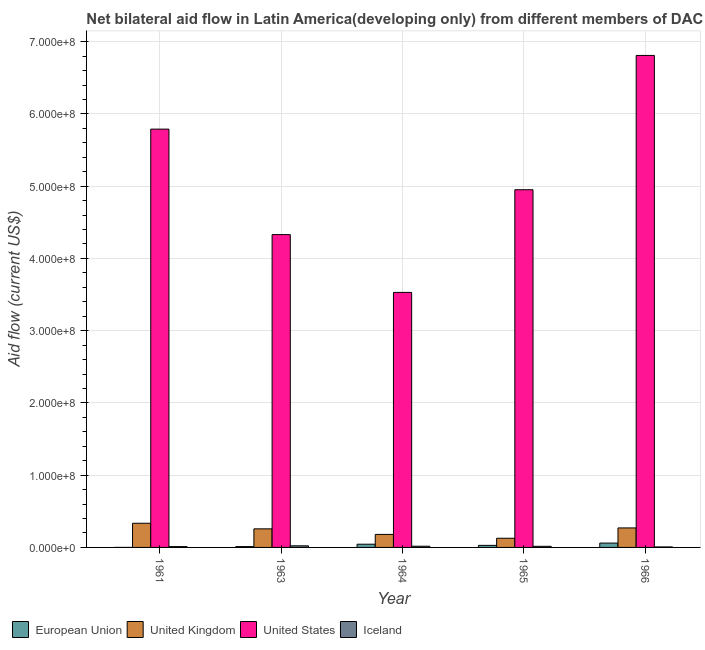How many different coloured bars are there?
Provide a short and direct response. 4. How many groups of bars are there?
Offer a very short reply. 5. What is the label of the 4th group of bars from the left?
Your answer should be compact. 1965. What is the amount of aid given by iceland in 1965?
Your answer should be compact. 1.53e+06. Across all years, what is the maximum amount of aid given by iceland?
Provide a succinct answer. 2.23e+06. Across all years, what is the minimum amount of aid given by iceland?
Ensure brevity in your answer.  6.80e+05. In which year was the amount of aid given by us maximum?
Your answer should be compact. 1966. In which year was the amount of aid given by iceland minimum?
Offer a very short reply. 1966. What is the total amount of aid given by eu in the graph?
Make the answer very short. 1.45e+07. What is the difference between the amount of aid given by iceland in 1961 and that in 1965?
Make the answer very short. -4.00e+05. What is the difference between the amount of aid given by iceland in 1964 and the amount of aid given by uk in 1961?
Keep it short and to the point. 5.40e+05. What is the average amount of aid given by eu per year?
Make the answer very short. 2.89e+06. What is the ratio of the amount of aid given by us in 1964 to that in 1965?
Offer a terse response. 0.71. Is the amount of aid given by uk in 1963 less than that in 1966?
Your answer should be compact. Yes. What is the difference between the highest and the second highest amount of aid given by us?
Ensure brevity in your answer.  1.02e+08. What is the difference between the highest and the lowest amount of aid given by eu?
Your answer should be compact. 6.00e+06. Is it the case that in every year, the sum of the amount of aid given by uk and amount of aid given by eu is greater than the sum of amount of aid given by us and amount of aid given by iceland?
Your answer should be compact. Yes. Is it the case that in every year, the sum of the amount of aid given by eu and amount of aid given by uk is greater than the amount of aid given by us?
Your answer should be very brief. No. How many bars are there?
Ensure brevity in your answer.  20. How many years are there in the graph?
Provide a succinct answer. 5. Are the values on the major ticks of Y-axis written in scientific E-notation?
Make the answer very short. Yes. Does the graph contain any zero values?
Your answer should be very brief. No. How are the legend labels stacked?
Ensure brevity in your answer.  Horizontal. What is the title of the graph?
Offer a terse response. Net bilateral aid flow in Latin America(developing only) from different members of DAC. What is the label or title of the Y-axis?
Offer a terse response. Aid flow (current US$). What is the Aid flow (current US$) of United Kingdom in 1961?
Keep it short and to the point. 3.34e+07. What is the Aid flow (current US$) of United States in 1961?
Ensure brevity in your answer.  5.79e+08. What is the Aid flow (current US$) of Iceland in 1961?
Your answer should be very brief. 1.13e+06. What is the Aid flow (current US$) in European Union in 1963?
Ensure brevity in your answer.  1.14e+06. What is the Aid flow (current US$) in United Kingdom in 1963?
Give a very brief answer. 2.57e+07. What is the Aid flow (current US$) of United States in 1963?
Give a very brief answer. 4.33e+08. What is the Aid flow (current US$) in Iceland in 1963?
Offer a terse response. 2.23e+06. What is the Aid flow (current US$) of European Union in 1964?
Keep it short and to the point. 4.45e+06. What is the Aid flow (current US$) of United Kingdom in 1964?
Your response must be concise. 1.80e+07. What is the Aid flow (current US$) of United States in 1964?
Keep it short and to the point. 3.53e+08. What is the Aid flow (current US$) of Iceland in 1964?
Offer a very short reply. 1.67e+06. What is the Aid flow (current US$) of European Union in 1965?
Give a very brief answer. 2.85e+06. What is the Aid flow (current US$) of United Kingdom in 1965?
Give a very brief answer. 1.27e+07. What is the Aid flow (current US$) in United States in 1965?
Your answer should be compact. 4.95e+08. What is the Aid flow (current US$) in Iceland in 1965?
Your answer should be very brief. 1.53e+06. What is the Aid flow (current US$) in European Union in 1966?
Give a very brief answer. 6.01e+06. What is the Aid flow (current US$) in United Kingdom in 1966?
Offer a very short reply. 2.70e+07. What is the Aid flow (current US$) of United States in 1966?
Offer a terse response. 6.81e+08. What is the Aid flow (current US$) in Iceland in 1966?
Offer a very short reply. 6.80e+05. Across all years, what is the maximum Aid flow (current US$) of European Union?
Provide a succinct answer. 6.01e+06. Across all years, what is the maximum Aid flow (current US$) of United Kingdom?
Make the answer very short. 3.34e+07. Across all years, what is the maximum Aid flow (current US$) in United States?
Provide a short and direct response. 6.81e+08. Across all years, what is the maximum Aid flow (current US$) of Iceland?
Provide a short and direct response. 2.23e+06. Across all years, what is the minimum Aid flow (current US$) of European Union?
Make the answer very short. 10000. Across all years, what is the minimum Aid flow (current US$) in United Kingdom?
Offer a very short reply. 1.27e+07. Across all years, what is the minimum Aid flow (current US$) of United States?
Keep it short and to the point. 3.53e+08. Across all years, what is the minimum Aid flow (current US$) in Iceland?
Offer a very short reply. 6.80e+05. What is the total Aid flow (current US$) of European Union in the graph?
Your answer should be very brief. 1.45e+07. What is the total Aid flow (current US$) of United Kingdom in the graph?
Keep it short and to the point. 1.17e+08. What is the total Aid flow (current US$) in United States in the graph?
Offer a terse response. 2.54e+09. What is the total Aid flow (current US$) in Iceland in the graph?
Your answer should be very brief. 7.24e+06. What is the difference between the Aid flow (current US$) in European Union in 1961 and that in 1963?
Your answer should be very brief. -1.13e+06. What is the difference between the Aid flow (current US$) of United Kingdom in 1961 and that in 1963?
Your answer should be compact. 7.73e+06. What is the difference between the Aid flow (current US$) of United States in 1961 and that in 1963?
Offer a terse response. 1.46e+08. What is the difference between the Aid flow (current US$) of Iceland in 1961 and that in 1963?
Offer a very short reply. -1.10e+06. What is the difference between the Aid flow (current US$) in European Union in 1961 and that in 1964?
Provide a succinct answer. -4.44e+06. What is the difference between the Aid flow (current US$) of United Kingdom in 1961 and that in 1964?
Keep it short and to the point. 1.54e+07. What is the difference between the Aid flow (current US$) of United States in 1961 and that in 1964?
Keep it short and to the point. 2.26e+08. What is the difference between the Aid flow (current US$) in Iceland in 1961 and that in 1964?
Make the answer very short. -5.40e+05. What is the difference between the Aid flow (current US$) of European Union in 1961 and that in 1965?
Give a very brief answer. -2.84e+06. What is the difference between the Aid flow (current US$) in United Kingdom in 1961 and that in 1965?
Your answer should be very brief. 2.07e+07. What is the difference between the Aid flow (current US$) of United States in 1961 and that in 1965?
Give a very brief answer. 8.39e+07. What is the difference between the Aid flow (current US$) of Iceland in 1961 and that in 1965?
Ensure brevity in your answer.  -4.00e+05. What is the difference between the Aid flow (current US$) in European Union in 1961 and that in 1966?
Provide a short and direct response. -6.00e+06. What is the difference between the Aid flow (current US$) of United Kingdom in 1961 and that in 1966?
Offer a terse response. 6.46e+06. What is the difference between the Aid flow (current US$) in United States in 1961 and that in 1966?
Make the answer very short. -1.02e+08. What is the difference between the Aid flow (current US$) of Iceland in 1961 and that in 1966?
Ensure brevity in your answer.  4.50e+05. What is the difference between the Aid flow (current US$) of European Union in 1963 and that in 1964?
Your answer should be very brief. -3.31e+06. What is the difference between the Aid flow (current US$) in United Kingdom in 1963 and that in 1964?
Your answer should be very brief. 7.70e+06. What is the difference between the Aid flow (current US$) in United States in 1963 and that in 1964?
Your answer should be compact. 8.00e+07. What is the difference between the Aid flow (current US$) of Iceland in 1963 and that in 1964?
Keep it short and to the point. 5.60e+05. What is the difference between the Aid flow (current US$) in European Union in 1963 and that in 1965?
Offer a very short reply. -1.71e+06. What is the difference between the Aid flow (current US$) in United Kingdom in 1963 and that in 1965?
Keep it short and to the point. 1.30e+07. What is the difference between the Aid flow (current US$) of United States in 1963 and that in 1965?
Your answer should be compact. -6.21e+07. What is the difference between the Aid flow (current US$) of Iceland in 1963 and that in 1965?
Provide a succinct answer. 7.00e+05. What is the difference between the Aid flow (current US$) of European Union in 1963 and that in 1966?
Offer a very short reply. -4.87e+06. What is the difference between the Aid flow (current US$) in United Kingdom in 1963 and that in 1966?
Your response must be concise. -1.27e+06. What is the difference between the Aid flow (current US$) in United States in 1963 and that in 1966?
Your answer should be very brief. -2.48e+08. What is the difference between the Aid flow (current US$) of Iceland in 1963 and that in 1966?
Provide a short and direct response. 1.55e+06. What is the difference between the Aid flow (current US$) of European Union in 1964 and that in 1965?
Provide a short and direct response. 1.60e+06. What is the difference between the Aid flow (current US$) in United Kingdom in 1964 and that in 1965?
Your answer should be very brief. 5.31e+06. What is the difference between the Aid flow (current US$) of United States in 1964 and that in 1965?
Your answer should be very brief. -1.42e+08. What is the difference between the Aid flow (current US$) in Iceland in 1964 and that in 1965?
Make the answer very short. 1.40e+05. What is the difference between the Aid flow (current US$) of European Union in 1964 and that in 1966?
Ensure brevity in your answer.  -1.56e+06. What is the difference between the Aid flow (current US$) of United Kingdom in 1964 and that in 1966?
Offer a very short reply. -8.97e+06. What is the difference between the Aid flow (current US$) of United States in 1964 and that in 1966?
Your answer should be compact. -3.28e+08. What is the difference between the Aid flow (current US$) of Iceland in 1964 and that in 1966?
Your response must be concise. 9.90e+05. What is the difference between the Aid flow (current US$) in European Union in 1965 and that in 1966?
Provide a succinct answer. -3.16e+06. What is the difference between the Aid flow (current US$) of United Kingdom in 1965 and that in 1966?
Your response must be concise. -1.43e+07. What is the difference between the Aid flow (current US$) of United States in 1965 and that in 1966?
Your answer should be compact. -1.86e+08. What is the difference between the Aid flow (current US$) in Iceland in 1965 and that in 1966?
Give a very brief answer. 8.50e+05. What is the difference between the Aid flow (current US$) in European Union in 1961 and the Aid flow (current US$) in United Kingdom in 1963?
Ensure brevity in your answer.  -2.57e+07. What is the difference between the Aid flow (current US$) of European Union in 1961 and the Aid flow (current US$) of United States in 1963?
Your response must be concise. -4.33e+08. What is the difference between the Aid flow (current US$) in European Union in 1961 and the Aid flow (current US$) in Iceland in 1963?
Your answer should be very brief. -2.22e+06. What is the difference between the Aid flow (current US$) of United Kingdom in 1961 and the Aid flow (current US$) of United States in 1963?
Keep it short and to the point. -4.00e+08. What is the difference between the Aid flow (current US$) in United Kingdom in 1961 and the Aid flow (current US$) in Iceland in 1963?
Provide a short and direct response. 3.12e+07. What is the difference between the Aid flow (current US$) in United States in 1961 and the Aid flow (current US$) in Iceland in 1963?
Keep it short and to the point. 5.77e+08. What is the difference between the Aid flow (current US$) in European Union in 1961 and the Aid flow (current US$) in United Kingdom in 1964?
Offer a terse response. -1.80e+07. What is the difference between the Aid flow (current US$) of European Union in 1961 and the Aid flow (current US$) of United States in 1964?
Ensure brevity in your answer.  -3.53e+08. What is the difference between the Aid flow (current US$) in European Union in 1961 and the Aid flow (current US$) in Iceland in 1964?
Ensure brevity in your answer.  -1.66e+06. What is the difference between the Aid flow (current US$) of United Kingdom in 1961 and the Aid flow (current US$) of United States in 1964?
Offer a very short reply. -3.20e+08. What is the difference between the Aid flow (current US$) of United Kingdom in 1961 and the Aid flow (current US$) of Iceland in 1964?
Make the answer very short. 3.18e+07. What is the difference between the Aid flow (current US$) in United States in 1961 and the Aid flow (current US$) in Iceland in 1964?
Provide a succinct answer. 5.77e+08. What is the difference between the Aid flow (current US$) in European Union in 1961 and the Aid flow (current US$) in United Kingdom in 1965?
Make the answer very short. -1.27e+07. What is the difference between the Aid flow (current US$) in European Union in 1961 and the Aid flow (current US$) in United States in 1965?
Your answer should be compact. -4.95e+08. What is the difference between the Aid flow (current US$) of European Union in 1961 and the Aid flow (current US$) of Iceland in 1965?
Keep it short and to the point. -1.52e+06. What is the difference between the Aid flow (current US$) of United Kingdom in 1961 and the Aid flow (current US$) of United States in 1965?
Your answer should be compact. -4.62e+08. What is the difference between the Aid flow (current US$) of United Kingdom in 1961 and the Aid flow (current US$) of Iceland in 1965?
Provide a short and direct response. 3.19e+07. What is the difference between the Aid flow (current US$) in United States in 1961 and the Aid flow (current US$) in Iceland in 1965?
Keep it short and to the point. 5.77e+08. What is the difference between the Aid flow (current US$) of European Union in 1961 and the Aid flow (current US$) of United Kingdom in 1966?
Keep it short and to the point. -2.70e+07. What is the difference between the Aid flow (current US$) in European Union in 1961 and the Aid flow (current US$) in United States in 1966?
Give a very brief answer. -6.81e+08. What is the difference between the Aid flow (current US$) in European Union in 1961 and the Aid flow (current US$) in Iceland in 1966?
Keep it short and to the point. -6.70e+05. What is the difference between the Aid flow (current US$) of United Kingdom in 1961 and the Aid flow (current US$) of United States in 1966?
Offer a very short reply. -6.48e+08. What is the difference between the Aid flow (current US$) of United Kingdom in 1961 and the Aid flow (current US$) of Iceland in 1966?
Your answer should be very brief. 3.28e+07. What is the difference between the Aid flow (current US$) in United States in 1961 and the Aid flow (current US$) in Iceland in 1966?
Provide a short and direct response. 5.78e+08. What is the difference between the Aid flow (current US$) of European Union in 1963 and the Aid flow (current US$) of United Kingdom in 1964?
Your answer should be compact. -1.69e+07. What is the difference between the Aid flow (current US$) in European Union in 1963 and the Aid flow (current US$) in United States in 1964?
Ensure brevity in your answer.  -3.52e+08. What is the difference between the Aid flow (current US$) of European Union in 1963 and the Aid flow (current US$) of Iceland in 1964?
Offer a very short reply. -5.30e+05. What is the difference between the Aid flow (current US$) of United Kingdom in 1963 and the Aid flow (current US$) of United States in 1964?
Make the answer very short. -3.27e+08. What is the difference between the Aid flow (current US$) of United Kingdom in 1963 and the Aid flow (current US$) of Iceland in 1964?
Provide a succinct answer. 2.40e+07. What is the difference between the Aid flow (current US$) in United States in 1963 and the Aid flow (current US$) in Iceland in 1964?
Your answer should be very brief. 4.31e+08. What is the difference between the Aid flow (current US$) of European Union in 1963 and the Aid flow (current US$) of United Kingdom in 1965?
Keep it short and to the point. -1.16e+07. What is the difference between the Aid flow (current US$) of European Union in 1963 and the Aid flow (current US$) of United States in 1965?
Ensure brevity in your answer.  -4.94e+08. What is the difference between the Aid flow (current US$) of European Union in 1963 and the Aid flow (current US$) of Iceland in 1965?
Offer a very short reply. -3.90e+05. What is the difference between the Aid flow (current US$) in United Kingdom in 1963 and the Aid flow (current US$) in United States in 1965?
Give a very brief answer. -4.69e+08. What is the difference between the Aid flow (current US$) in United Kingdom in 1963 and the Aid flow (current US$) in Iceland in 1965?
Your answer should be very brief. 2.42e+07. What is the difference between the Aid flow (current US$) in United States in 1963 and the Aid flow (current US$) in Iceland in 1965?
Your response must be concise. 4.31e+08. What is the difference between the Aid flow (current US$) of European Union in 1963 and the Aid flow (current US$) of United Kingdom in 1966?
Ensure brevity in your answer.  -2.58e+07. What is the difference between the Aid flow (current US$) of European Union in 1963 and the Aid flow (current US$) of United States in 1966?
Provide a succinct answer. -6.80e+08. What is the difference between the Aid flow (current US$) of European Union in 1963 and the Aid flow (current US$) of Iceland in 1966?
Provide a succinct answer. 4.60e+05. What is the difference between the Aid flow (current US$) in United Kingdom in 1963 and the Aid flow (current US$) in United States in 1966?
Offer a very short reply. -6.55e+08. What is the difference between the Aid flow (current US$) in United Kingdom in 1963 and the Aid flow (current US$) in Iceland in 1966?
Offer a terse response. 2.50e+07. What is the difference between the Aid flow (current US$) of United States in 1963 and the Aid flow (current US$) of Iceland in 1966?
Provide a short and direct response. 4.32e+08. What is the difference between the Aid flow (current US$) of European Union in 1964 and the Aid flow (current US$) of United Kingdom in 1965?
Your response must be concise. -8.26e+06. What is the difference between the Aid flow (current US$) of European Union in 1964 and the Aid flow (current US$) of United States in 1965?
Make the answer very short. -4.91e+08. What is the difference between the Aid flow (current US$) in European Union in 1964 and the Aid flow (current US$) in Iceland in 1965?
Your answer should be compact. 2.92e+06. What is the difference between the Aid flow (current US$) in United Kingdom in 1964 and the Aid flow (current US$) in United States in 1965?
Ensure brevity in your answer.  -4.77e+08. What is the difference between the Aid flow (current US$) of United Kingdom in 1964 and the Aid flow (current US$) of Iceland in 1965?
Make the answer very short. 1.65e+07. What is the difference between the Aid flow (current US$) of United States in 1964 and the Aid flow (current US$) of Iceland in 1965?
Provide a succinct answer. 3.51e+08. What is the difference between the Aid flow (current US$) of European Union in 1964 and the Aid flow (current US$) of United Kingdom in 1966?
Your answer should be compact. -2.25e+07. What is the difference between the Aid flow (current US$) in European Union in 1964 and the Aid flow (current US$) in United States in 1966?
Provide a short and direct response. -6.77e+08. What is the difference between the Aid flow (current US$) in European Union in 1964 and the Aid flow (current US$) in Iceland in 1966?
Your response must be concise. 3.77e+06. What is the difference between the Aid flow (current US$) of United Kingdom in 1964 and the Aid flow (current US$) of United States in 1966?
Your response must be concise. -6.63e+08. What is the difference between the Aid flow (current US$) of United Kingdom in 1964 and the Aid flow (current US$) of Iceland in 1966?
Provide a succinct answer. 1.73e+07. What is the difference between the Aid flow (current US$) in United States in 1964 and the Aid flow (current US$) in Iceland in 1966?
Your answer should be compact. 3.52e+08. What is the difference between the Aid flow (current US$) in European Union in 1965 and the Aid flow (current US$) in United Kingdom in 1966?
Keep it short and to the point. -2.41e+07. What is the difference between the Aid flow (current US$) of European Union in 1965 and the Aid flow (current US$) of United States in 1966?
Offer a terse response. -6.78e+08. What is the difference between the Aid flow (current US$) in European Union in 1965 and the Aid flow (current US$) in Iceland in 1966?
Your response must be concise. 2.17e+06. What is the difference between the Aid flow (current US$) in United Kingdom in 1965 and the Aid flow (current US$) in United States in 1966?
Keep it short and to the point. -6.68e+08. What is the difference between the Aid flow (current US$) in United Kingdom in 1965 and the Aid flow (current US$) in Iceland in 1966?
Your response must be concise. 1.20e+07. What is the difference between the Aid flow (current US$) in United States in 1965 and the Aid flow (current US$) in Iceland in 1966?
Keep it short and to the point. 4.94e+08. What is the average Aid flow (current US$) of European Union per year?
Offer a terse response. 2.89e+06. What is the average Aid flow (current US$) of United Kingdom per year?
Your answer should be very brief. 2.34e+07. What is the average Aid flow (current US$) in United States per year?
Offer a terse response. 5.08e+08. What is the average Aid flow (current US$) in Iceland per year?
Keep it short and to the point. 1.45e+06. In the year 1961, what is the difference between the Aid flow (current US$) of European Union and Aid flow (current US$) of United Kingdom?
Your answer should be compact. -3.34e+07. In the year 1961, what is the difference between the Aid flow (current US$) in European Union and Aid flow (current US$) in United States?
Offer a very short reply. -5.79e+08. In the year 1961, what is the difference between the Aid flow (current US$) in European Union and Aid flow (current US$) in Iceland?
Ensure brevity in your answer.  -1.12e+06. In the year 1961, what is the difference between the Aid flow (current US$) in United Kingdom and Aid flow (current US$) in United States?
Your answer should be very brief. -5.46e+08. In the year 1961, what is the difference between the Aid flow (current US$) in United Kingdom and Aid flow (current US$) in Iceland?
Provide a succinct answer. 3.23e+07. In the year 1961, what is the difference between the Aid flow (current US$) of United States and Aid flow (current US$) of Iceland?
Give a very brief answer. 5.78e+08. In the year 1963, what is the difference between the Aid flow (current US$) in European Union and Aid flow (current US$) in United Kingdom?
Ensure brevity in your answer.  -2.46e+07. In the year 1963, what is the difference between the Aid flow (current US$) in European Union and Aid flow (current US$) in United States?
Ensure brevity in your answer.  -4.32e+08. In the year 1963, what is the difference between the Aid flow (current US$) of European Union and Aid flow (current US$) of Iceland?
Provide a succinct answer. -1.09e+06. In the year 1963, what is the difference between the Aid flow (current US$) of United Kingdom and Aid flow (current US$) of United States?
Your response must be concise. -4.07e+08. In the year 1963, what is the difference between the Aid flow (current US$) in United Kingdom and Aid flow (current US$) in Iceland?
Make the answer very short. 2.35e+07. In the year 1963, what is the difference between the Aid flow (current US$) of United States and Aid flow (current US$) of Iceland?
Make the answer very short. 4.31e+08. In the year 1964, what is the difference between the Aid flow (current US$) in European Union and Aid flow (current US$) in United Kingdom?
Offer a terse response. -1.36e+07. In the year 1964, what is the difference between the Aid flow (current US$) of European Union and Aid flow (current US$) of United States?
Your response must be concise. -3.49e+08. In the year 1964, what is the difference between the Aid flow (current US$) in European Union and Aid flow (current US$) in Iceland?
Give a very brief answer. 2.78e+06. In the year 1964, what is the difference between the Aid flow (current US$) of United Kingdom and Aid flow (current US$) of United States?
Your answer should be very brief. -3.35e+08. In the year 1964, what is the difference between the Aid flow (current US$) in United Kingdom and Aid flow (current US$) in Iceland?
Your answer should be compact. 1.64e+07. In the year 1964, what is the difference between the Aid flow (current US$) of United States and Aid flow (current US$) of Iceland?
Your answer should be very brief. 3.51e+08. In the year 1965, what is the difference between the Aid flow (current US$) of European Union and Aid flow (current US$) of United Kingdom?
Provide a short and direct response. -9.86e+06. In the year 1965, what is the difference between the Aid flow (current US$) in European Union and Aid flow (current US$) in United States?
Ensure brevity in your answer.  -4.92e+08. In the year 1965, what is the difference between the Aid flow (current US$) of European Union and Aid flow (current US$) of Iceland?
Ensure brevity in your answer.  1.32e+06. In the year 1965, what is the difference between the Aid flow (current US$) of United Kingdom and Aid flow (current US$) of United States?
Give a very brief answer. -4.82e+08. In the year 1965, what is the difference between the Aid flow (current US$) in United Kingdom and Aid flow (current US$) in Iceland?
Provide a short and direct response. 1.12e+07. In the year 1965, what is the difference between the Aid flow (current US$) in United States and Aid flow (current US$) in Iceland?
Your answer should be compact. 4.94e+08. In the year 1966, what is the difference between the Aid flow (current US$) of European Union and Aid flow (current US$) of United Kingdom?
Offer a very short reply. -2.10e+07. In the year 1966, what is the difference between the Aid flow (current US$) of European Union and Aid flow (current US$) of United States?
Your answer should be very brief. -6.75e+08. In the year 1966, what is the difference between the Aid flow (current US$) of European Union and Aid flow (current US$) of Iceland?
Your response must be concise. 5.33e+06. In the year 1966, what is the difference between the Aid flow (current US$) in United Kingdom and Aid flow (current US$) in United States?
Offer a terse response. -6.54e+08. In the year 1966, what is the difference between the Aid flow (current US$) of United Kingdom and Aid flow (current US$) of Iceland?
Your answer should be compact. 2.63e+07. In the year 1966, what is the difference between the Aid flow (current US$) in United States and Aid flow (current US$) in Iceland?
Offer a very short reply. 6.80e+08. What is the ratio of the Aid flow (current US$) of European Union in 1961 to that in 1963?
Provide a short and direct response. 0.01. What is the ratio of the Aid flow (current US$) of United Kingdom in 1961 to that in 1963?
Make the answer very short. 1.3. What is the ratio of the Aid flow (current US$) in United States in 1961 to that in 1963?
Your answer should be very brief. 1.34. What is the ratio of the Aid flow (current US$) in Iceland in 1961 to that in 1963?
Provide a short and direct response. 0.51. What is the ratio of the Aid flow (current US$) in European Union in 1961 to that in 1964?
Offer a very short reply. 0. What is the ratio of the Aid flow (current US$) in United Kingdom in 1961 to that in 1964?
Your response must be concise. 1.86. What is the ratio of the Aid flow (current US$) of United States in 1961 to that in 1964?
Give a very brief answer. 1.64. What is the ratio of the Aid flow (current US$) of Iceland in 1961 to that in 1964?
Give a very brief answer. 0.68. What is the ratio of the Aid flow (current US$) in European Union in 1961 to that in 1965?
Offer a very short reply. 0. What is the ratio of the Aid flow (current US$) in United Kingdom in 1961 to that in 1965?
Provide a succinct answer. 2.63. What is the ratio of the Aid flow (current US$) of United States in 1961 to that in 1965?
Offer a very short reply. 1.17. What is the ratio of the Aid flow (current US$) of Iceland in 1961 to that in 1965?
Provide a succinct answer. 0.74. What is the ratio of the Aid flow (current US$) of European Union in 1961 to that in 1966?
Provide a succinct answer. 0. What is the ratio of the Aid flow (current US$) of United Kingdom in 1961 to that in 1966?
Ensure brevity in your answer.  1.24. What is the ratio of the Aid flow (current US$) of United States in 1961 to that in 1966?
Give a very brief answer. 0.85. What is the ratio of the Aid flow (current US$) of Iceland in 1961 to that in 1966?
Your answer should be very brief. 1.66. What is the ratio of the Aid flow (current US$) in European Union in 1963 to that in 1964?
Provide a short and direct response. 0.26. What is the ratio of the Aid flow (current US$) in United Kingdom in 1963 to that in 1964?
Your answer should be compact. 1.43. What is the ratio of the Aid flow (current US$) in United States in 1963 to that in 1964?
Give a very brief answer. 1.23. What is the ratio of the Aid flow (current US$) in Iceland in 1963 to that in 1964?
Your response must be concise. 1.34. What is the ratio of the Aid flow (current US$) of United Kingdom in 1963 to that in 1965?
Your answer should be compact. 2.02. What is the ratio of the Aid flow (current US$) in United States in 1963 to that in 1965?
Provide a short and direct response. 0.87. What is the ratio of the Aid flow (current US$) of Iceland in 1963 to that in 1965?
Provide a succinct answer. 1.46. What is the ratio of the Aid flow (current US$) in European Union in 1963 to that in 1966?
Your response must be concise. 0.19. What is the ratio of the Aid flow (current US$) of United Kingdom in 1963 to that in 1966?
Provide a short and direct response. 0.95. What is the ratio of the Aid flow (current US$) in United States in 1963 to that in 1966?
Ensure brevity in your answer.  0.64. What is the ratio of the Aid flow (current US$) of Iceland in 1963 to that in 1966?
Provide a succinct answer. 3.28. What is the ratio of the Aid flow (current US$) of European Union in 1964 to that in 1965?
Keep it short and to the point. 1.56. What is the ratio of the Aid flow (current US$) of United Kingdom in 1964 to that in 1965?
Offer a very short reply. 1.42. What is the ratio of the Aid flow (current US$) of United States in 1964 to that in 1965?
Ensure brevity in your answer.  0.71. What is the ratio of the Aid flow (current US$) in Iceland in 1964 to that in 1965?
Keep it short and to the point. 1.09. What is the ratio of the Aid flow (current US$) of European Union in 1964 to that in 1966?
Offer a terse response. 0.74. What is the ratio of the Aid flow (current US$) in United Kingdom in 1964 to that in 1966?
Give a very brief answer. 0.67. What is the ratio of the Aid flow (current US$) of United States in 1964 to that in 1966?
Offer a very short reply. 0.52. What is the ratio of the Aid flow (current US$) of Iceland in 1964 to that in 1966?
Your response must be concise. 2.46. What is the ratio of the Aid flow (current US$) of European Union in 1965 to that in 1966?
Provide a succinct answer. 0.47. What is the ratio of the Aid flow (current US$) of United Kingdom in 1965 to that in 1966?
Offer a terse response. 0.47. What is the ratio of the Aid flow (current US$) of United States in 1965 to that in 1966?
Ensure brevity in your answer.  0.73. What is the ratio of the Aid flow (current US$) of Iceland in 1965 to that in 1966?
Your answer should be very brief. 2.25. What is the difference between the highest and the second highest Aid flow (current US$) of European Union?
Provide a succinct answer. 1.56e+06. What is the difference between the highest and the second highest Aid flow (current US$) in United Kingdom?
Offer a very short reply. 6.46e+06. What is the difference between the highest and the second highest Aid flow (current US$) of United States?
Your response must be concise. 1.02e+08. What is the difference between the highest and the second highest Aid flow (current US$) in Iceland?
Your response must be concise. 5.60e+05. What is the difference between the highest and the lowest Aid flow (current US$) of United Kingdom?
Ensure brevity in your answer.  2.07e+07. What is the difference between the highest and the lowest Aid flow (current US$) in United States?
Ensure brevity in your answer.  3.28e+08. What is the difference between the highest and the lowest Aid flow (current US$) in Iceland?
Keep it short and to the point. 1.55e+06. 